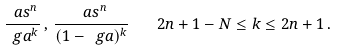Convert formula to latex. <formula><loc_0><loc_0><loc_500><loc_500>\frac { \ a s ^ { n } } { \ g a ^ { k } } \, , \, \frac { \ a s ^ { n } } { ( 1 - \ g a ) ^ { k } } \quad 2 n + 1 - N \leq k \leq 2 n + 1 \, .</formula> 